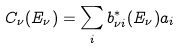<formula> <loc_0><loc_0><loc_500><loc_500>C _ { \nu } ( E _ { \nu } ) = \sum _ { i } b _ { \nu i } ^ { * } ( E _ { \nu } ) a _ { i }</formula> 